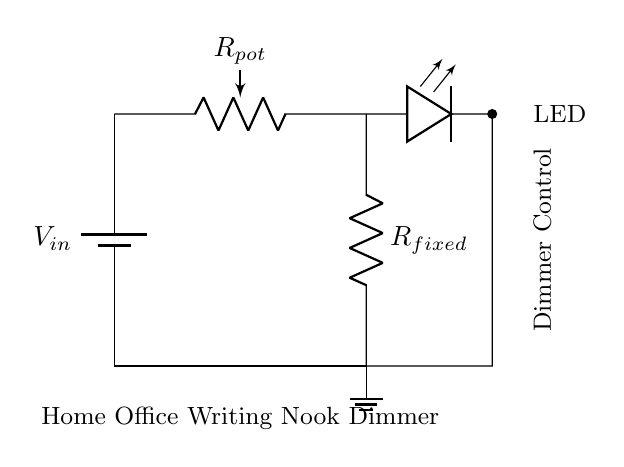What is the main purpose of this circuit? The circuit is designed to create a dimmer switch for controlling the brightness of an LED in a home office writing nook.
Answer: dimmer switch What component is used to adjust resistance in this circuit? The potentiometer is the component that allows for adjustment of resistance, facilitating the brightness control of the LED.
Answer: potentiometer Which components are in series in this circuit? The circuit consists of the potentiometer and the fixed resistor, both connected in series from the power source to the ground.
Answer: potentiometer and fixed resistor If the potentiometer is at maximum resistance, what happens to the LED brightness? At maximum resistance, the voltage drop across the LED decreases significantly, which leads to dimmer or no light emitted from the LED, showing that less current flows through the circuit.
Answer: dimmer or off What is the voltage at the LED when the potentiometer is set to half its resistance? The voltage at the LED will be approximately half of the input voltage, depending on the fixed resistor's value and the total circuit resistance at that point, illustrating the voltage divider principle at work.
Answer: half of Vin What is the type of circuit shown? The circuit is a voltage divider circuit, which is typically used to generate a variable output voltage suitable for controlling an LED's brightness.
Answer: voltage divider What happens to the total resistance when the potentiometer is adjusted to lower resistance? When the potentiometer's resistance is lowered, the total resistance in the circuit decreases, allowing more current to flow and consequently making the LED brighter.
Answer: decreases 